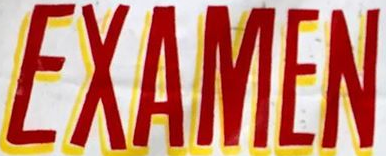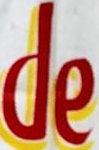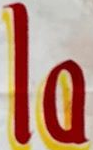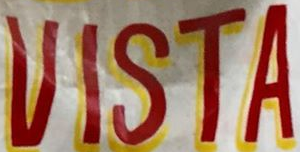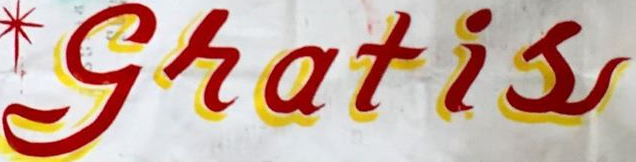What words can you see in these images in sequence, separated by a semicolon? EXAMEN; de; la; VISTA; gratis 